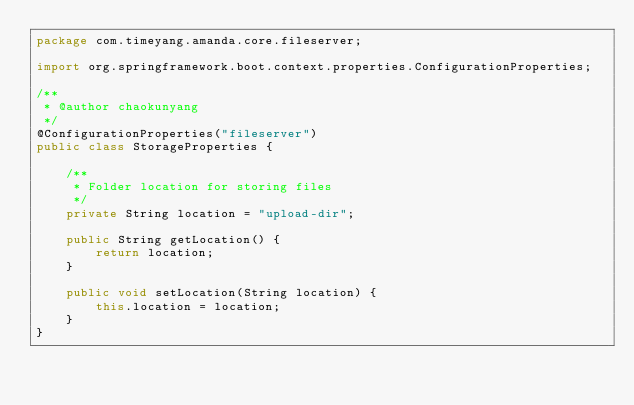Convert code to text. <code><loc_0><loc_0><loc_500><loc_500><_Java_>package com.timeyang.amanda.core.fileserver;

import org.springframework.boot.context.properties.ConfigurationProperties;

/**
 * @author chaokunyang
 */
@ConfigurationProperties("fileserver")
public class StorageProperties {

    /**
     * Folder location for storing files
     */
    private String location = "upload-dir";

    public String getLocation() {
        return location;
    }

    public void setLocation(String location) {
        this.location = location;
    }
}
</code> 